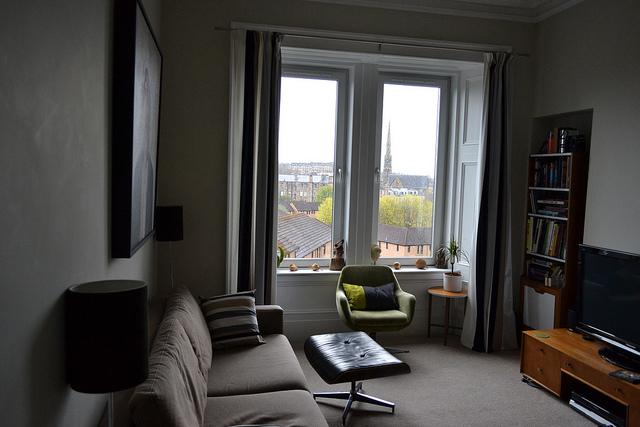What color is the left side of the pillow sitting on the single seat? Please explain your reasoning. yellow. The pillow on the chair by the window is black on the right and yellow on the left. 